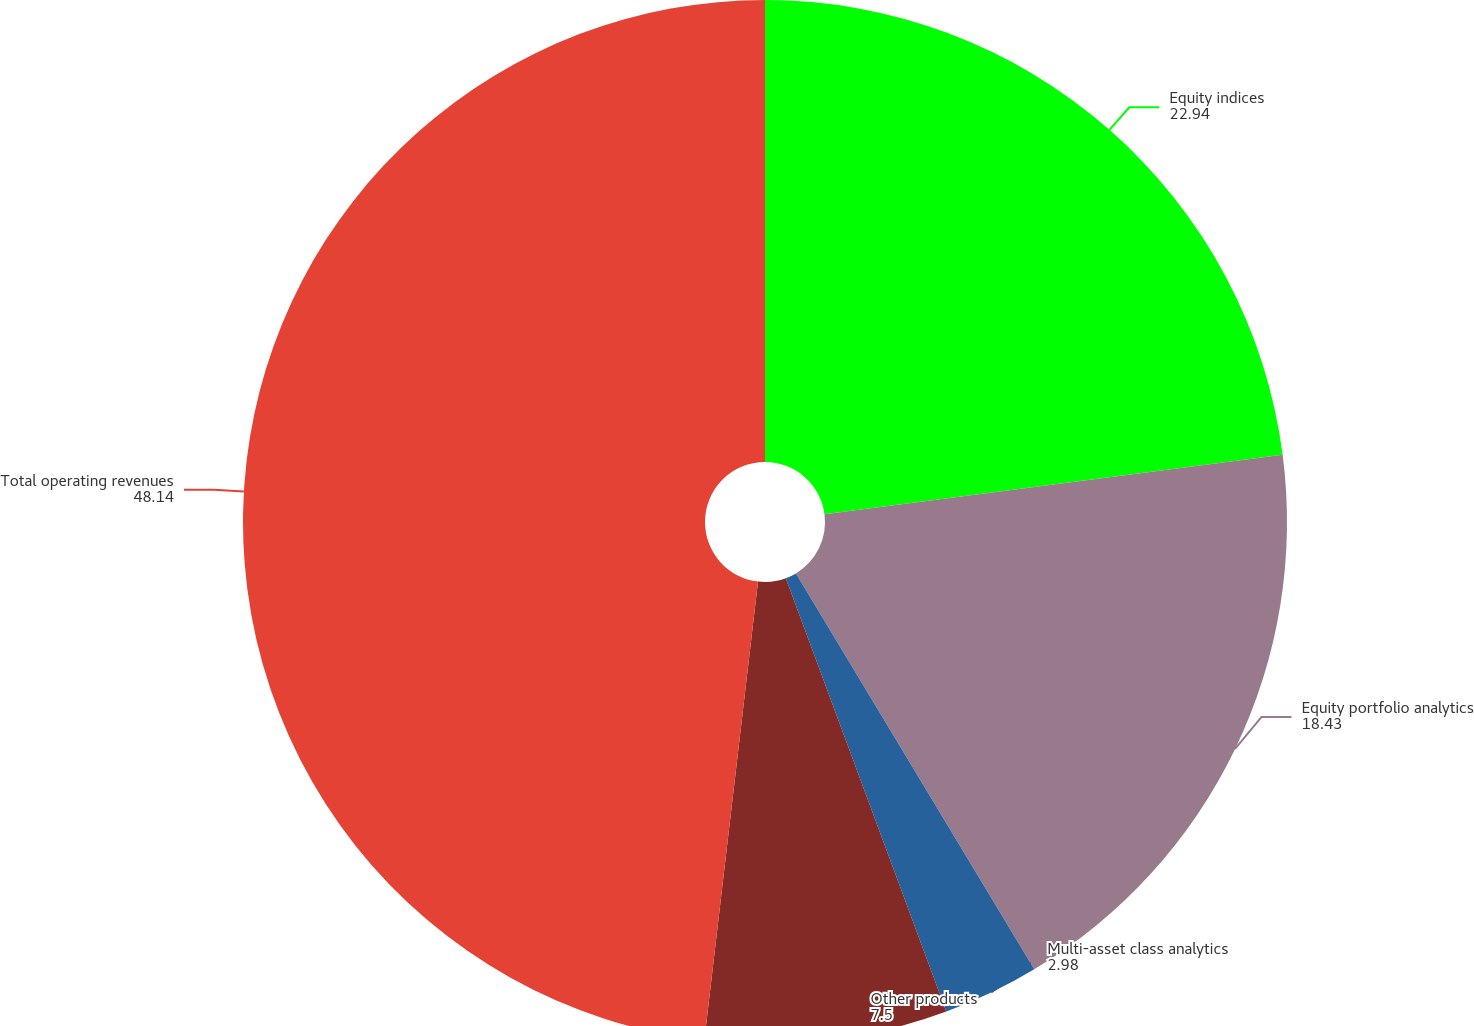Convert chart to OTSL. <chart><loc_0><loc_0><loc_500><loc_500><pie_chart><fcel>Equity indices<fcel>Equity portfolio analytics<fcel>Multi-asset class analytics<fcel>Other products<fcel>Total operating revenues<nl><fcel>22.94%<fcel>18.43%<fcel>2.98%<fcel>7.5%<fcel>48.14%<nl></chart> 